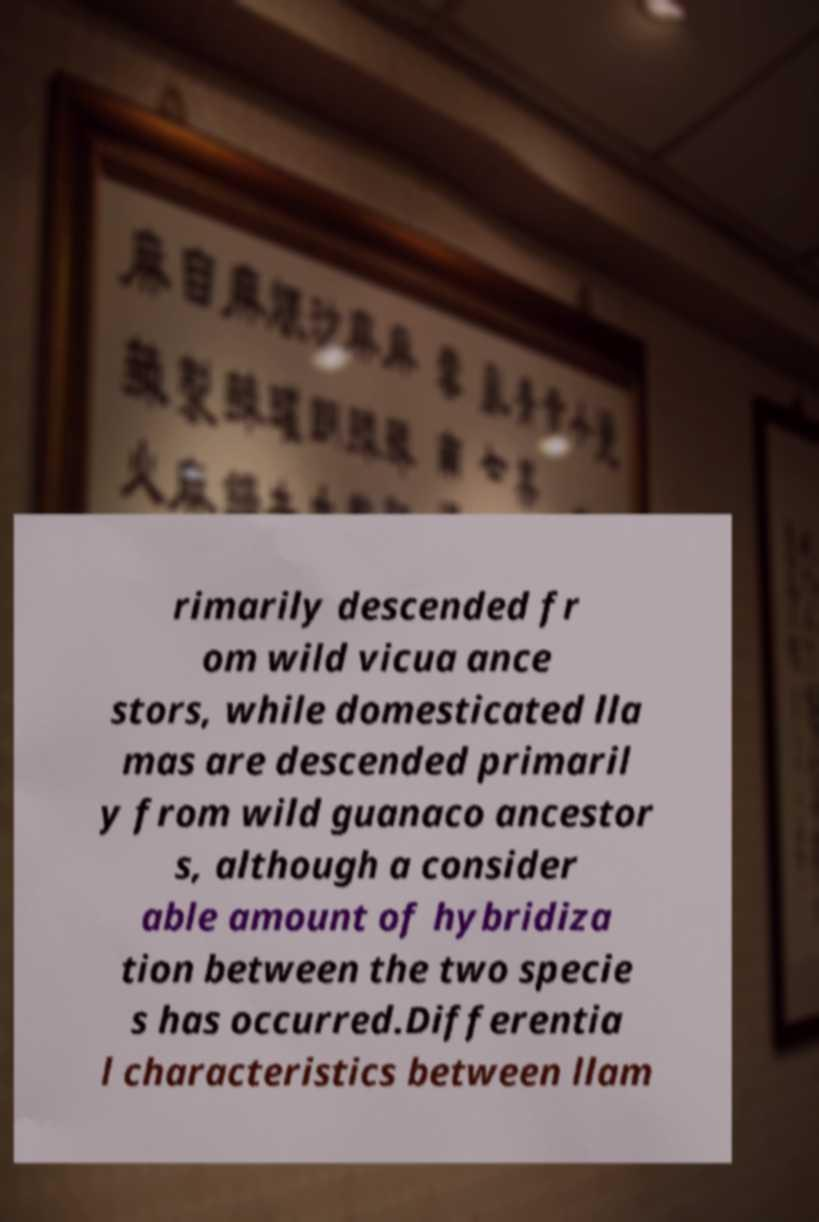Please identify and transcribe the text found in this image. rimarily descended fr om wild vicua ance stors, while domesticated lla mas are descended primaril y from wild guanaco ancestor s, although a consider able amount of hybridiza tion between the two specie s has occurred.Differentia l characteristics between llam 